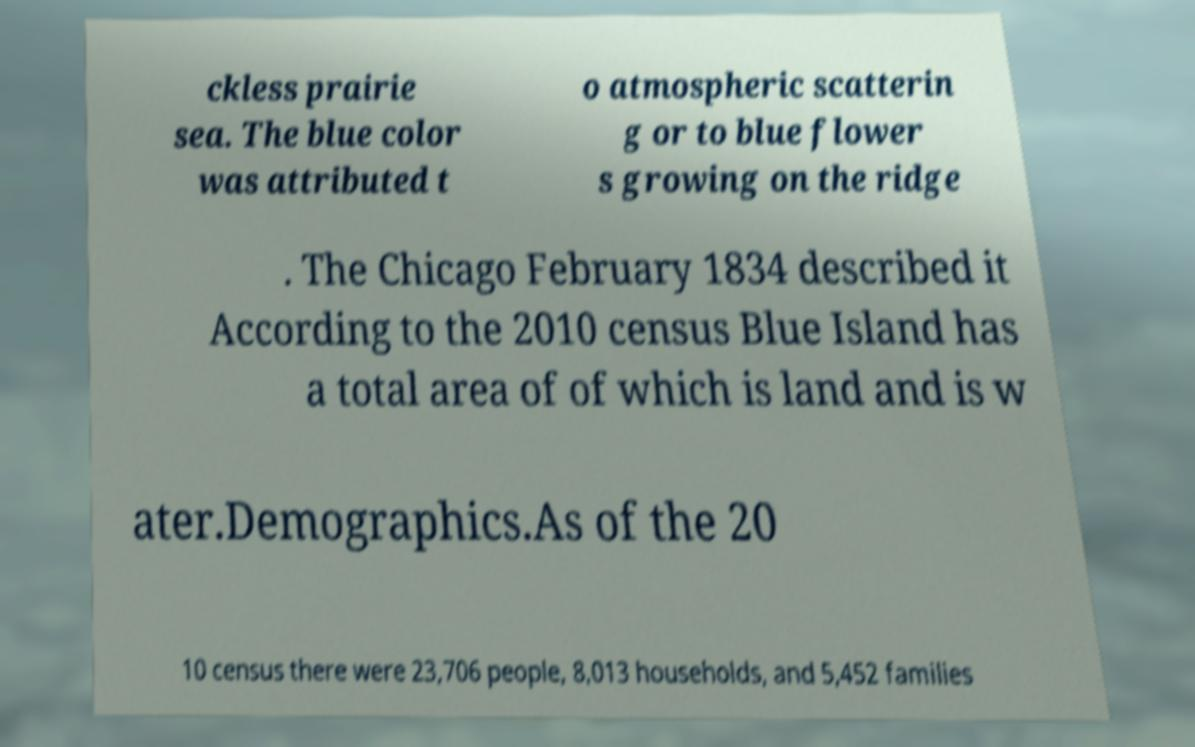For documentation purposes, I need the text within this image transcribed. Could you provide that? ckless prairie sea. The blue color was attributed t o atmospheric scatterin g or to blue flower s growing on the ridge . The Chicago February 1834 described it According to the 2010 census Blue Island has a total area of of which is land and is w ater.Demographics.As of the 20 10 census there were 23,706 people, 8,013 households, and 5,452 families 